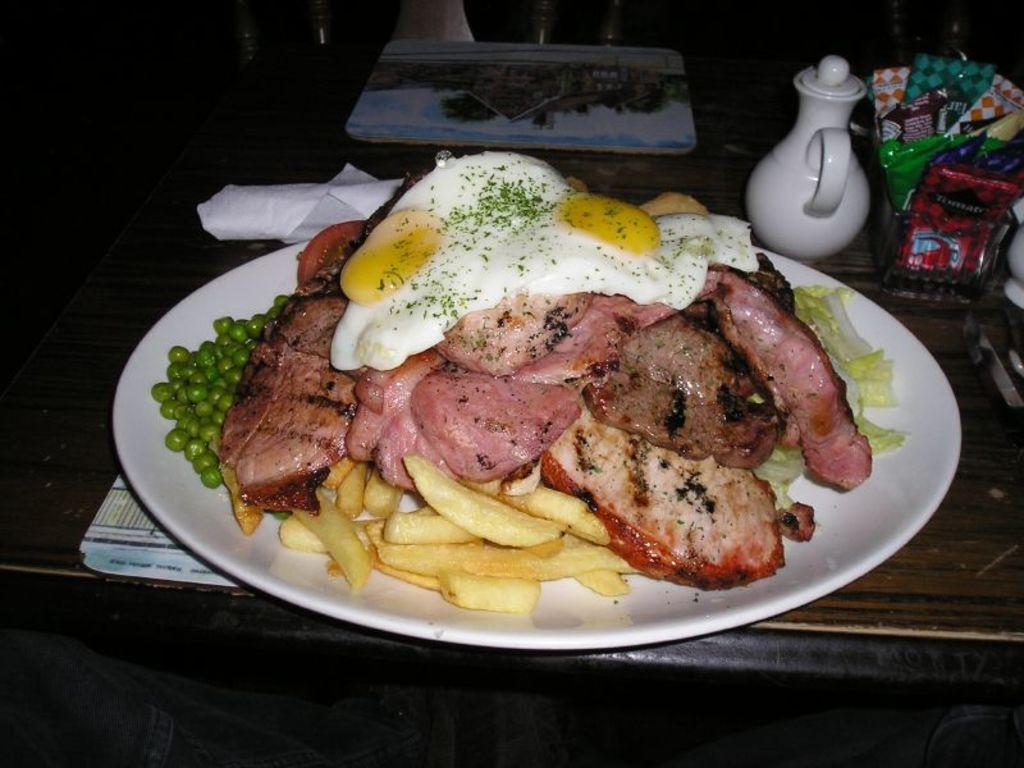What is on the plate that is visible in the image? There are food items on a plate in the image. What is under the plate in the image? There are table mats in the image. What is the container with a handle in the image? There is a jug in the image. What else can be seen on the table in the image? There are other items on the table in the image. What can be seen in the background of the image? There are objects visible in the background of the image. How many pizzas are being served in the image? There are no pizzas present in the image. 